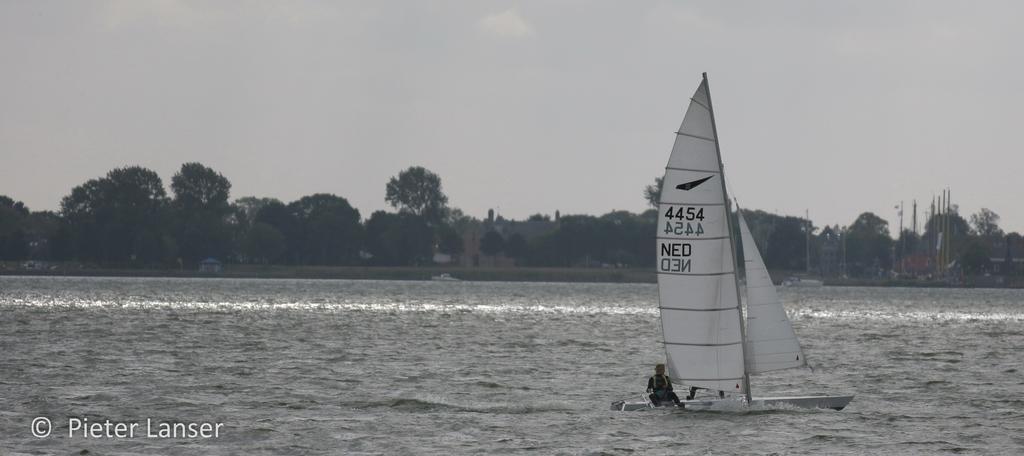Please provide a concise description of this image. At the bottom of the image there is water. On the water there is a boat with pole and cloth. And there is a person sitting in the boat. In the background there are trees, buildings and poles. At the top of the image there is sky. 